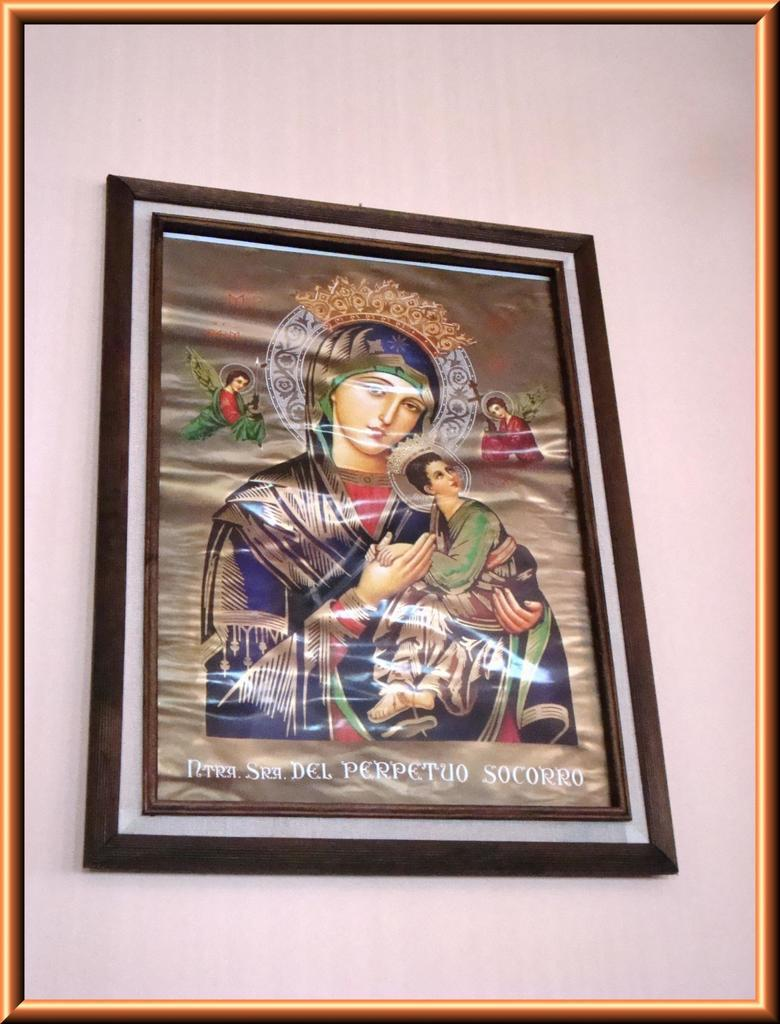What is present on the wall in the image? There is a photo frame on the wall in the image. What can be seen in the photo frame? The content of the photo frame is not mentioned in the facts, so we cannot determine what is inside it. Is there any text visible in the image? Yes, there is text visible in the image. How many books are stacked on the wall in the image? There is no mention of books in the image, so we cannot determine the number of books present. 